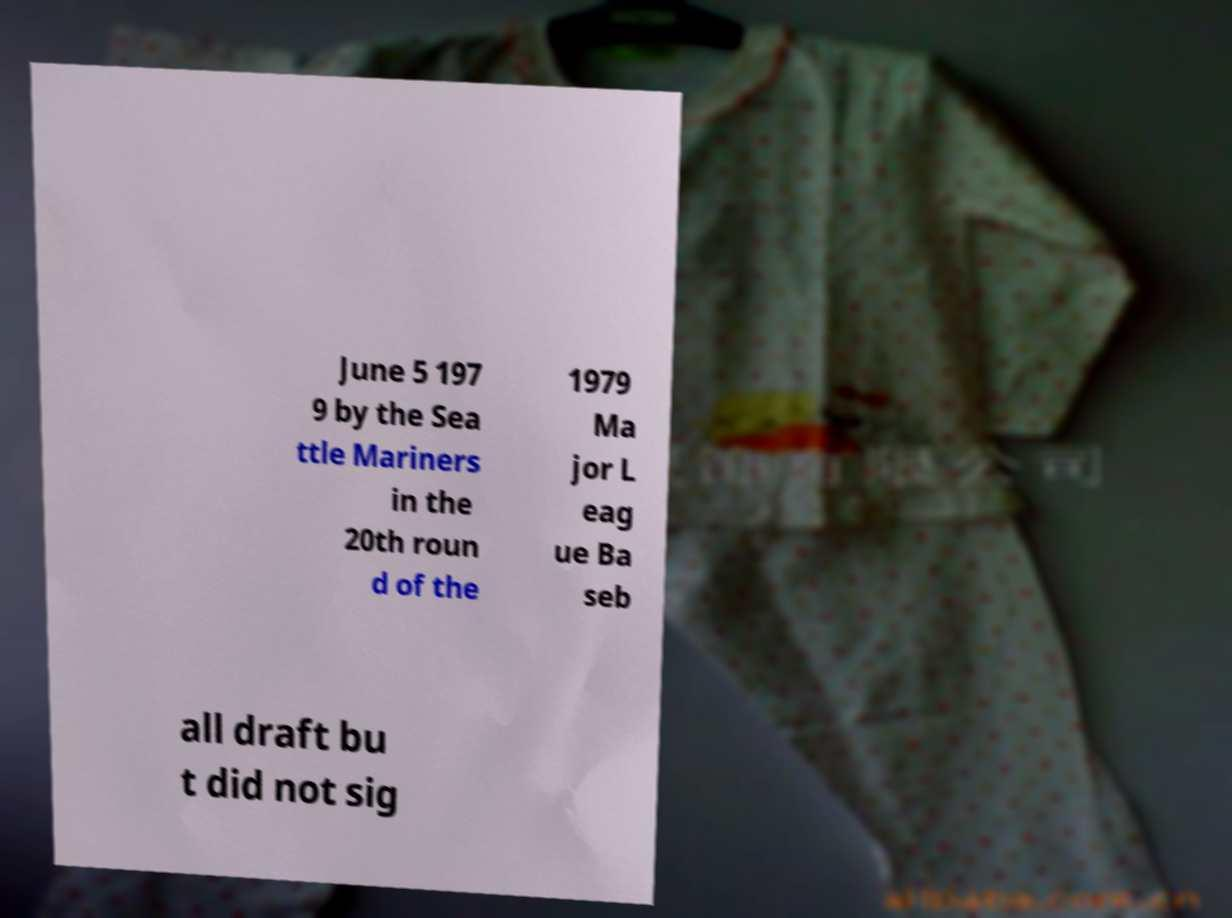For documentation purposes, I need the text within this image transcribed. Could you provide that? June 5 197 9 by the Sea ttle Mariners in the 20th roun d of the 1979 Ma jor L eag ue Ba seb all draft bu t did not sig 